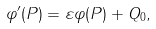Convert formula to latex. <formula><loc_0><loc_0><loc_500><loc_500>\varphi ^ { \prime } ( P ) = \varepsilon \varphi ( P ) + Q _ { 0 } ,</formula> 